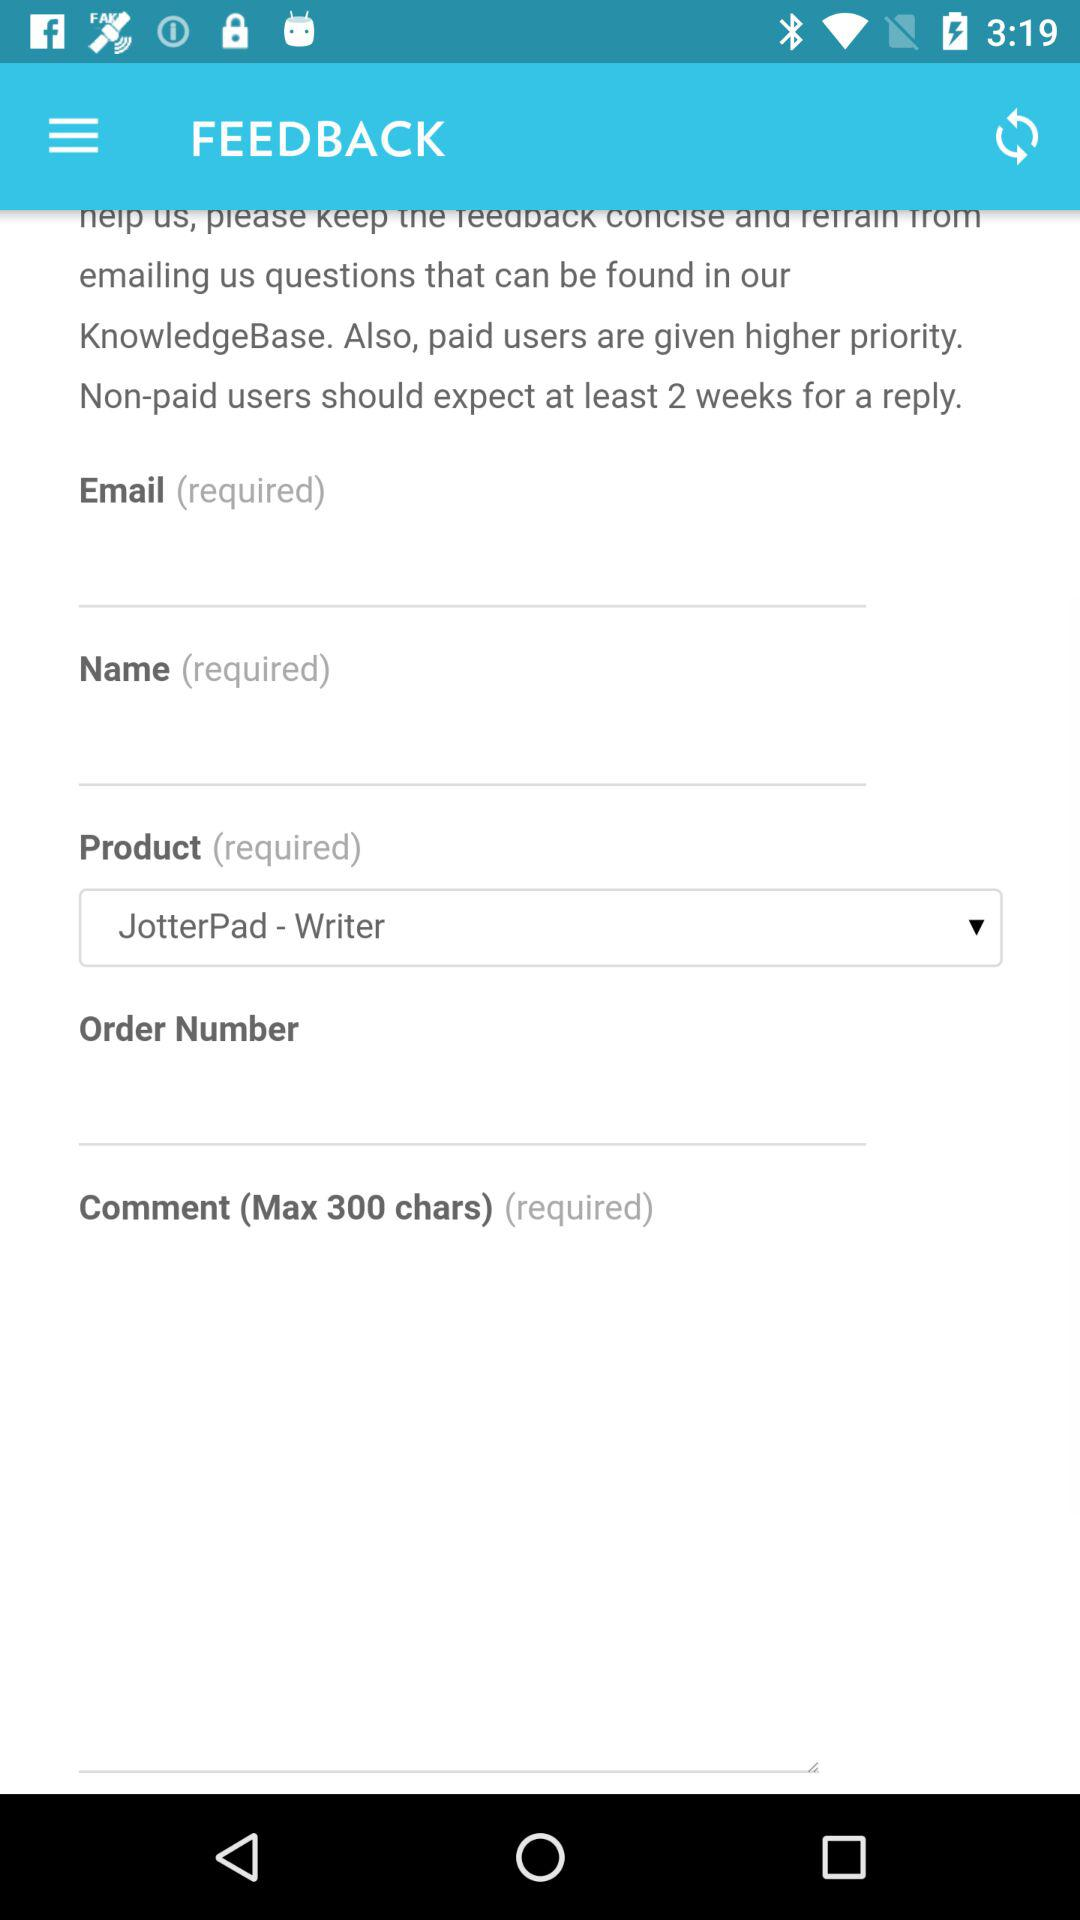For how many weeks will the non-paid users wait for a reply? The non-paid user will wait for a reply for at least 2 weeks. 